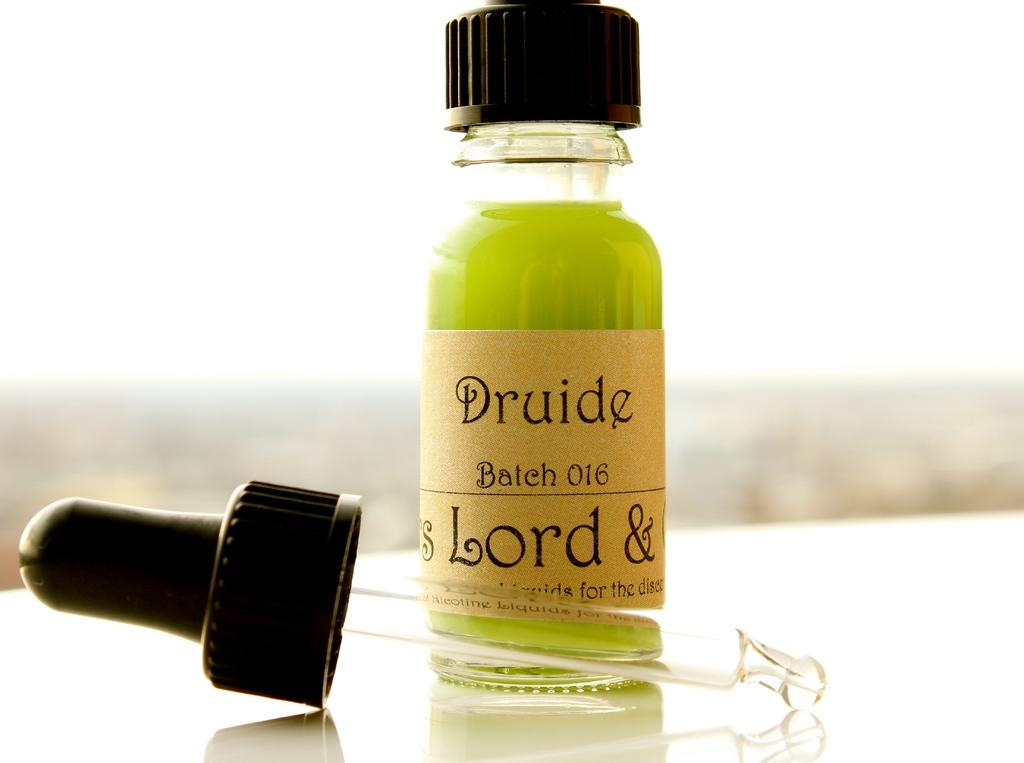<image>
Provide a brief description of the given image. A bottle of Druide batch 016 has a lime green liquid in it. 